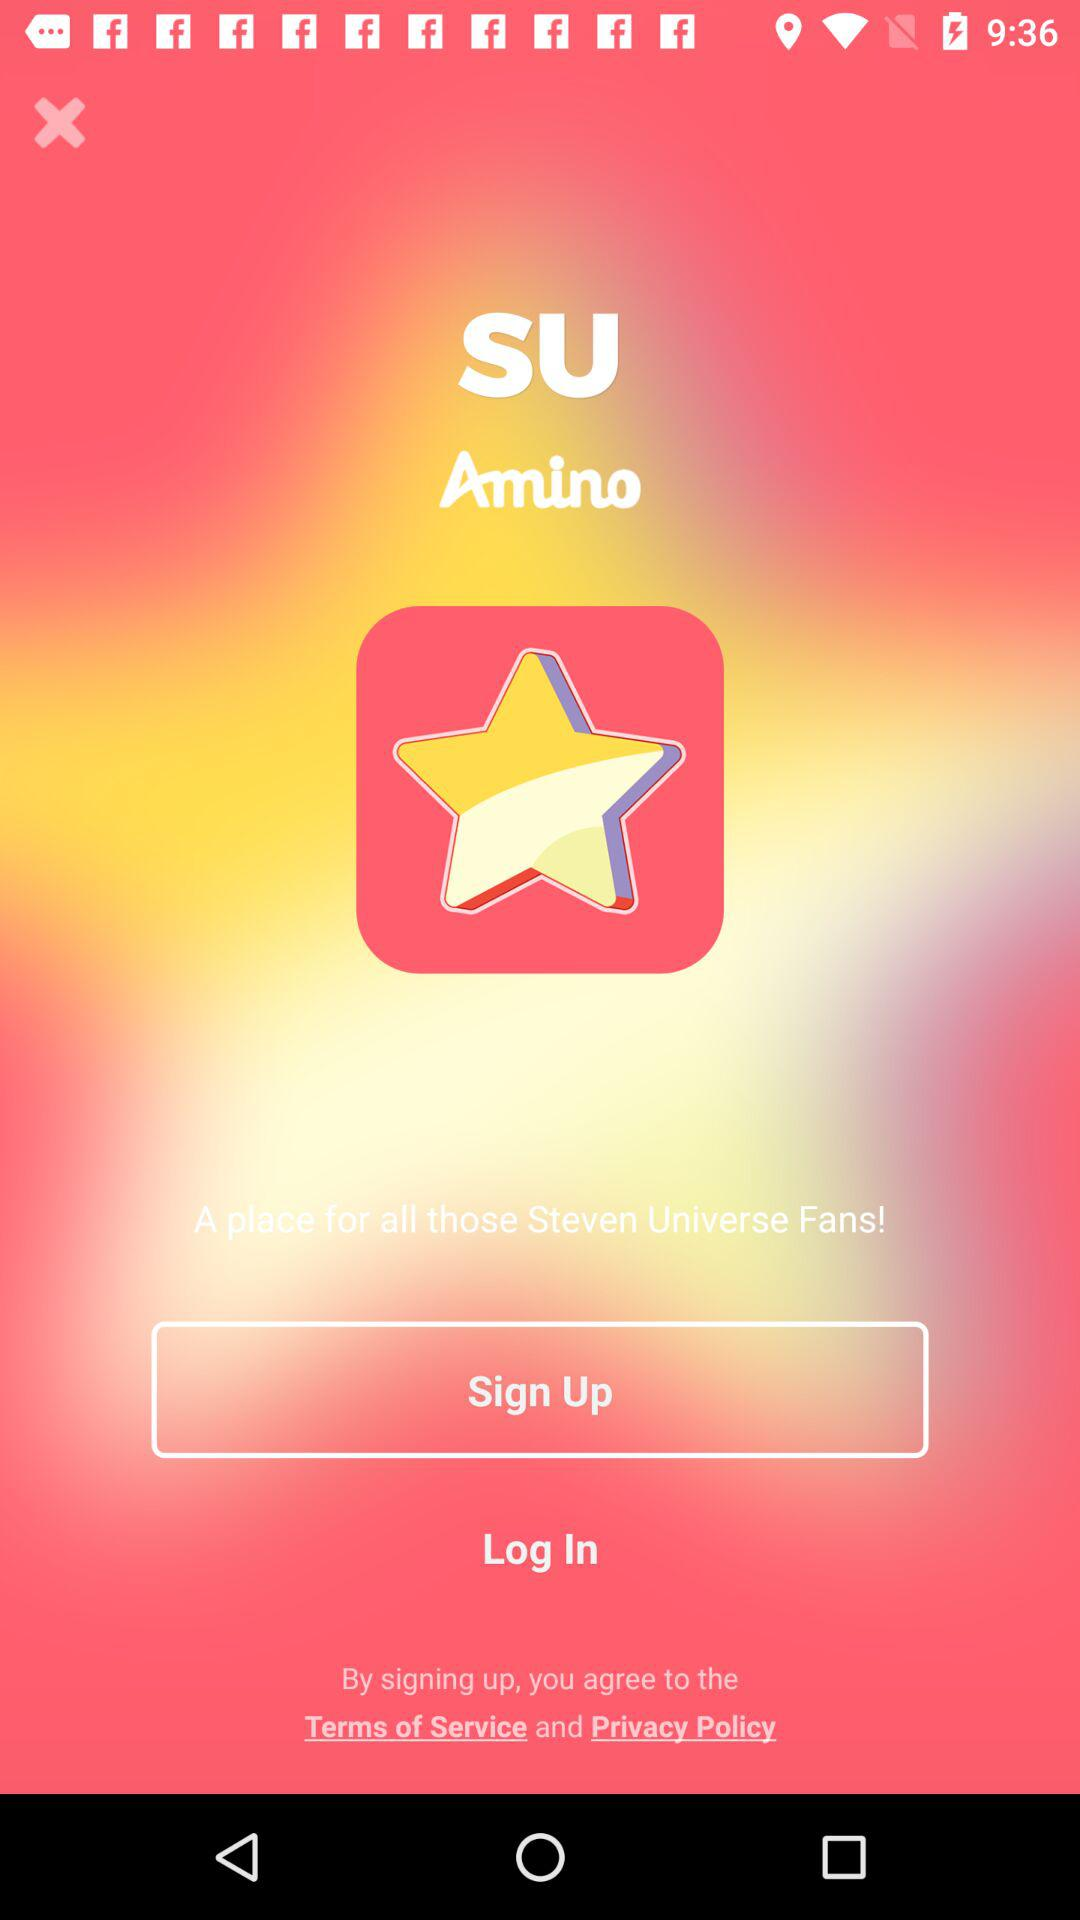What is the name of the application? The application name is "SU Amino". 